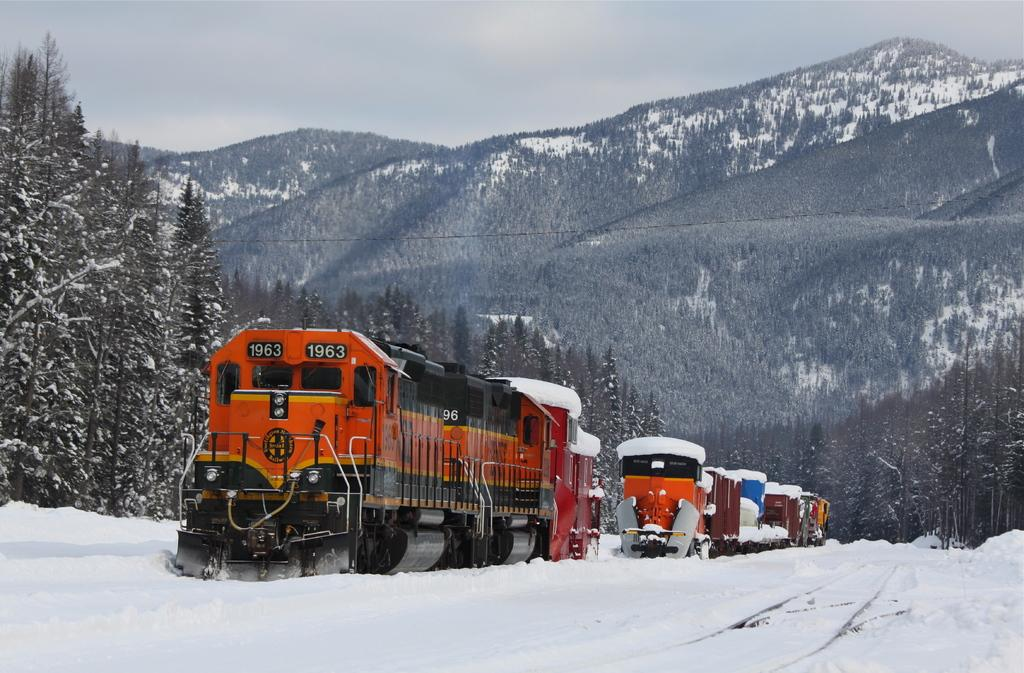What type of vehicles can be seen in the image? There are trains in the image. What type of natural features are present in the image? There are trees and mountains in the image. What is the weather like in the image? There is snow in the image, indicating a cold or wintry environment. What can be seen in the background of the image? The sky is visible in the background of the image. Can you see any ghosts writing a message on the side of the train in the image? There are no ghosts or any writing present on the trains in the image. 